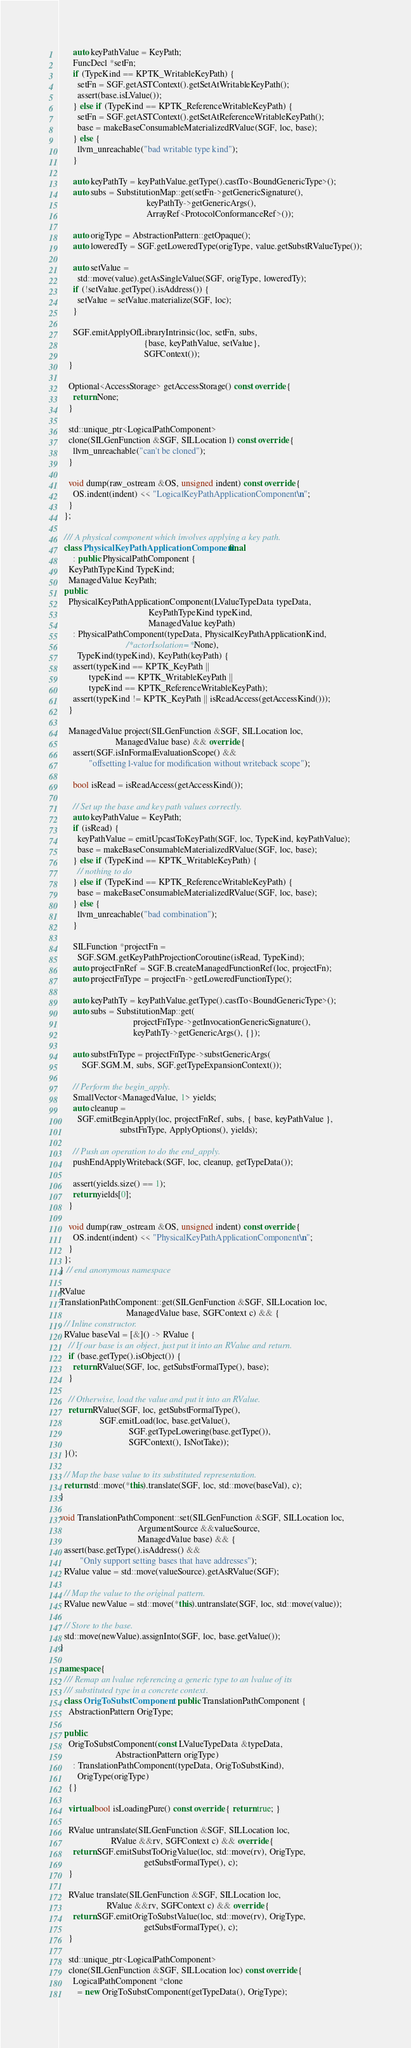<code> <loc_0><loc_0><loc_500><loc_500><_C++_>      auto keyPathValue = KeyPath;
      FuncDecl *setFn;
      if (TypeKind == KPTK_WritableKeyPath) {
        setFn = SGF.getASTContext().getSetAtWritableKeyPath();
        assert(base.isLValue());
      } else if (TypeKind == KPTK_ReferenceWritableKeyPath) {
        setFn = SGF.getASTContext().getSetAtReferenceWritableKeyPath();
        base = makeBaseConsumableMaterializedRValue(SGF, loc, base);
      } else {
        llvm_unreachable("bad writable type kind");
      }

      auto keyPathTy = keyPathValue.getType().castTo<BoundGenericType>();
      auto subs = SubstitutionMap::get(setFn->getGenericSignature(),
                                       keyPathTy->getGenericArgs(),
                                       ArrayRef<ProtocolConformanceRef>());

      auto origType = AbstractionPattern::getOpaque();
      auto loweredTy = SGF.getLoweredType(origType, value.getSubstRValueType());

      auto setValue =
        std::move(value).getAsSingleValue(SGF, origType, loweredTy);
      if (!setValue.getType().isAddress()) {
        setValue = setValue.materialize(SGF, loc);
      }

      SGF.emitApplyOfLibraryIntrinsic(loc, setFn, subs,
                                      {base, keyPathValue, setValue},
                                      SGFContext());
    }

    Optional<AccessStorage> getAccessStorage() const override {
      return None;
    }

    std::unique_ptr<LogicalPathComponent>
    clone(SILGenFunction &SGF, SILLocation l) const override {
      llvm_unreachable("can't be cloned");
    }

    void dump(raw_ostream &OS, unsigned indent) const override {
      OS.indent(indent) << "LogicalKeyPathApplicationComponent\n";
    }
  };

  /// A physical component which involves applying a key path.
  class PhysicalKeyPathApplicationComponent final
      : public PhysicalPathComponent {
    KeyPathTypeKind TypeKind;
    ManagedValue KeyPath;
  public:
    PhysicalKeyPathApplicationComponent(LValueTypeData typeData,
                                        KeyPathTypeKind typeKind,
                                        ManagedValue keyPath)
      : PhysicalPathComponent(typeData, PhysicalKeyPathApplicationKind,
                              /*actorIsolation=*/None),
        TypeKind(typeKind), KeyPath(keyPath) {
      assert(typeKind == KPTK_KeyPath ||
             typeKind == KPTK_WritableKeyPath ||
             typeKind == KPTK_ReferenceWritableKeyPath);
      assert(typeKind != KPTK_KeyPath || isReadAccess(getAccessKind()));
    }

    ManagedValue project(SILGenFunction &SGF, SILLocation loc,
                         ManagedValue base) && override {
      assert(SGF.isInFormalEvaluationScope() &&
             "offsetting l-value for modification without writeback scope");

      bool isRead = isReadAccess(getAccessKind());

      // Set up the base and key path values correctly.
      auto keyPathValue = KeyPath;
      if (isRead) {
        keyPathValue = emitUpcastToKeyPath(SGF, loc, TypeKind, keyPathValue);
        base = makeBaseConsumableMaterializedRValue(SGF, loc, base);
      } else if (TypeKind == KPTK_WritableKeyPath) {
        // nothing to do
      } else if (TypeKind == KPTK_ReferenceWritableKeyPath) {
        base = makeBaseConsumableMaterializedRValue(SGF, loc, base);
      } else {
        llvm_unreachable("bad combination");
      }

      SILFunction *projectFn =
        SGF.SGM.getKeyPathProjectionCoroutine(isRead, TypeKind);
      auto projectFnRef = SGF.B.createManagedFunctionRef(loc, projectFn);
      auto projectFnType = projectFn->getLoweredFunctionType();

      auto keyPathTy = keyPathValue.getType().castTo<BoundGenericType>();
      auto subs = SubstitutionMap::get(
                                 projectFnType->getInvocationGenericSignature(),
                                 keyPathTy->getGenericArgs(), {});

      auto substFnType = projectFnType->substGenericArgs(
          SGF.SGM.M, subs, SGF.getTypeExpansionContext());

      // Perform the begin_apply.
      SmallVector<ManagedValue, 1> yields;
      auto cleanup =
        SGF.emitBeginApply(loc, projectFnRef, subs, { base, keyPathValue },
                           substFnType, ApplyOptions(), yields);

      // Push an operation to do the end_apply.
      pushEndApplyWriteback(SGF, loc, cleanup, getTypeData());

      assert(yields.size() == 1);
      return yields[0];
    }

    void dump(raw_ostream &OS, unsigned indent) const override {
      OS.indent(indent) << "PhysicalKeyPathApplicationComponent\n";
    }
  };
} // end anonymous namespace

RValue
TranslationPathComponent::get(SILGenFunction &SGF, SILLocation loc,
                              ManagedValue base, SGFContext c) && {
  // Inline constructor.
  RValue baseVal = [&]() -> RValue {
    // If our base is an object, just put it into an RValue and return.
    if (base.getType().isObject()) {
      return RValue(SGF, loc, getSubstFormalType(), base);
    }

    // Otherwise, load the value and put it into an RValue.
    return RValue(SGF, loc, getSubstFormalType(),
                  SGF.emitLoad(loc, base.getValue(),
                               SGF.getTypeLowering(base.getType()),
                               SGFContext(), IsNotTake));
  }();

  // Map the base value to its substituted representation.
  return std::move(*this).translate(SGF, loc, std::move(baseVal), c);
}

void TranslationPathComponent::set(SILGenFunction &SGF, SILLocation loc,
                                   ArgumentSource &&valueSource,
                                   ManagedValue base) && {
  assert(base.getType().isAddress() &&
         "Only support setting bases that have addresses");
  RValue value = std::move(valueSource).getAsRValue(SGF);

  // Map the value to the original pattern.
  RValue newValue = std::move(*this).untranslate(SGF, loc, std::move(value));

  // Store to the base.
  std::move(newValue).assignInto(SGF, loc, base.getValue());
}

namespace {
  /// Remap an lvalue referencing a generic type to an lvalue of its
  /// substituted type in a concrete context.
  class OrigToSubstComponent : public TranslationPathComponent {
    AbstractionPattern OrigType;

  public:
    OrigToSubstComponent(const LValueTypeData &typeData,
                         AbstractionPattern origType)
      : TranslationPathComponent(typeData, OrigToSubstKind),
        OrigType(origType)
    {}

    virtual bool isLoadingPure() const override { return true; }

    RValue untranslate(SILGenFunction &SGF, SILLocation loc,
                       RValue &&rv, SGFContext c) && override {
      return SGF.emitSubstToOrigValue(loc, std::move(rv), OrigType,
                                      getSubstFormalType(), c);
    }

    RValue translate(SILGenFunction &SGF, SILLocation loc,
                     RValue &&rv, SGFContext c) && override {
      return SGF.emitOrigToSubstValue(loc, std::move(rv), OrigType,
                                      getSubstFormalType(), c);
    }

    std::unique_ptr<LogicalPathComponent>
    clone(SILGenFunction &SGF, SILLocation loc) const override {
      LogicalPathComponent *clone
        = new OrigToSubstComponent(getTypeData(), OrigType);</code> 